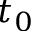Convert formula to latex. <formula><loc_0><loc_0><loc_500><loc_500>t _ { 0 }</formula> 